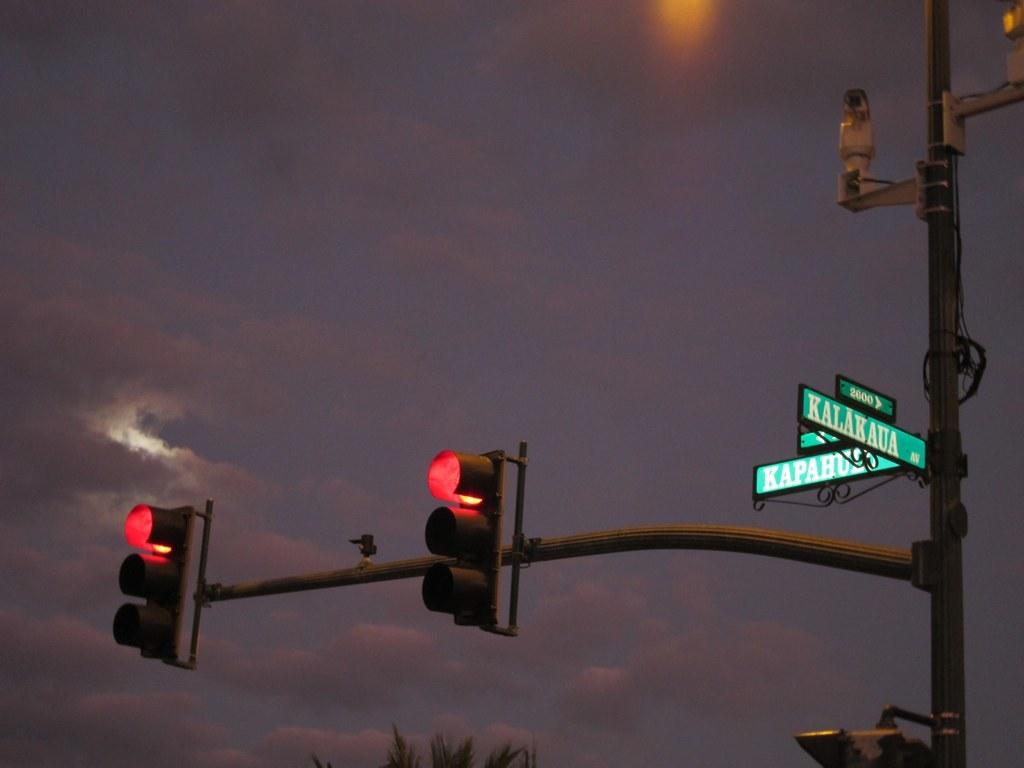What is the person in the image doing? The person in the image is sitting on a bench. Where is the bench located? The bench is located in a park. What can be seen in the park? There is a pond with ducks in it. What else is visible in the background of the image? There are trees and a playground in the background. What type of force is being applied to the powder in the image? There is no powder or force present in the image; it features a person sitting on a bench in a park. 